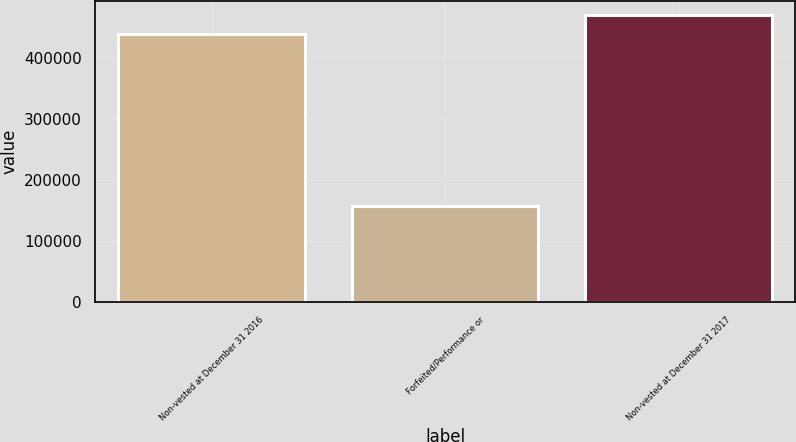Convert chart. <chart><loc_0><loc_0><loc_500><loc_500><bar_chart><fcel>Non-vested at December 31 2016<fcel>Forfeited/Performance or<fcel>Non-vested at December 31 2017<nl><fcel>438302<fcel>157699<fcel>469313<nl></chart> 